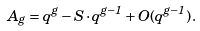<formula> <loc_0><loc_0><loc_500><loc_500>A _ { g } = q ^ { g } - S \cdot q ^ { g - 1 } + O ( q ^ { g - 1 } ) \, .</formula> 